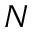Convert formula to latex. <formula><loc_0><loc_0><loc_500><loc_500>N</formula> 